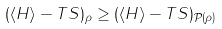<formula> <loc_0><loc_0><loc_500><loc_500>( \langle H \rangle - T S ) _ { \rho } \geq ( \langle H \rangle - T S ) _ { \mathcal { P } ( \rho ) }</formula> 